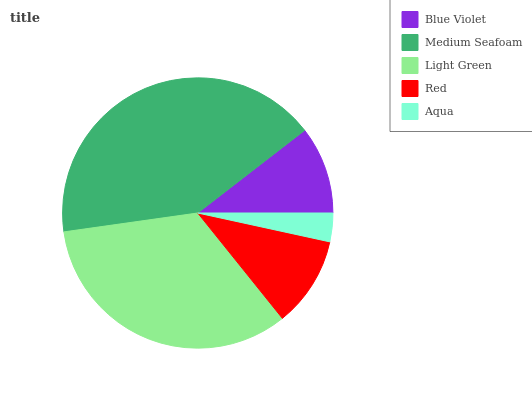Is Aqua the minimum?
Answer yes or no. Yes. Is Medium Seafoam the maximum?
Answer yes or no. Yes. Is Light Green the minimum?
Answer yes or no. No. Is Light Green the maximum?
Answer yes or no. No. Is Medium Seafoam greater than Light Green?
Answer yes or no. Yes. Is Light Green less than Medium Seafoam?
Answer yes or no. Yes. Is Light Green greater than Medium Seafoam?
Answer yes or no. No. Is Medium Seafoam less than Light Green?
Answer yes or no. No. Is Red the high median?
Answer yes or no. Yes. Is Red the low median?
Answer yes or no. Yes. Is Light Green the high median?
Answer yes or no. No. Is Medium Seafoam the low median?
Answer yes or no. No. 